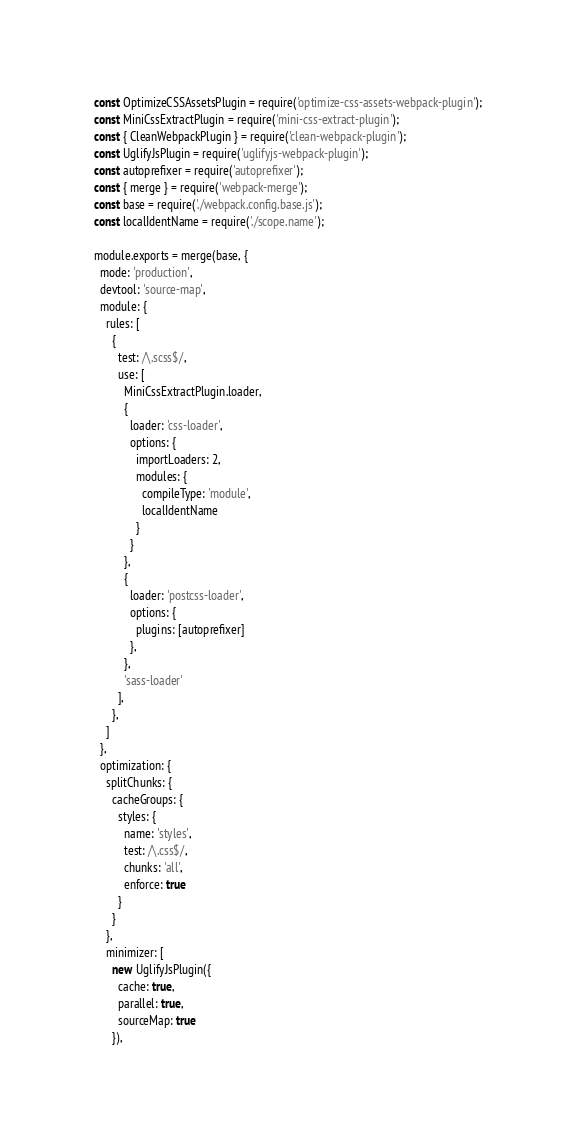<code> <loc_0><loc_0><loc_500><loc_500><_JavaScript_>const OptimizeCSSAssetsPlugin = require('optimize-css-assets-webpack-plugin');
const MiniCssExtractPlugin = require('mini-css-extract-plugin');
const { CleanWebpackPlugin } = require('clean-webpack-plugin');
const UglifyJsPlugin = require('uglifyjs-webpack-plugin');
const autoprefixer = require('autoprefixer');
const { merge } = require('webpack-merge');
const base = require('./webpack.config.base.js');
const localIdentName = require('./scope.name');

module.exports = merge(base, {
  mode: 'production',
  devtool: 'source-map',
  module: {
    rules: [
      {
        test: /\.scss$/,
        use: [
          MiniCssExtractPlugin.loader,
          {
            loader: 'css-loader',
            options: {
              importLoaders: 2,
              modules: {
                compileType: 'module',
                localIdentName
              }
            }
          },
          {
            loader: 'postcss-loader',
            options: {
              plugins: [autoprefixer]
            },
          },
          'sass-loader'
        ],
      },
    ]
  },
  optimization: {
    splitChunks: {
      cacheGroups: {
        styles: {
          name: 'styles',
          test: /\.css$/,
          chunks: 'all',
          enforce: true
        }
      }
    },
    minimizer: [
      new UglifyJsPlugin({
        cache: true,
        parallel: true,
        sourceMap: true
      }),</code> 